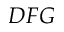Convert formula to latex. <formula><loc_0><loc_0><loc_500><loc_500>D F G</formula> 